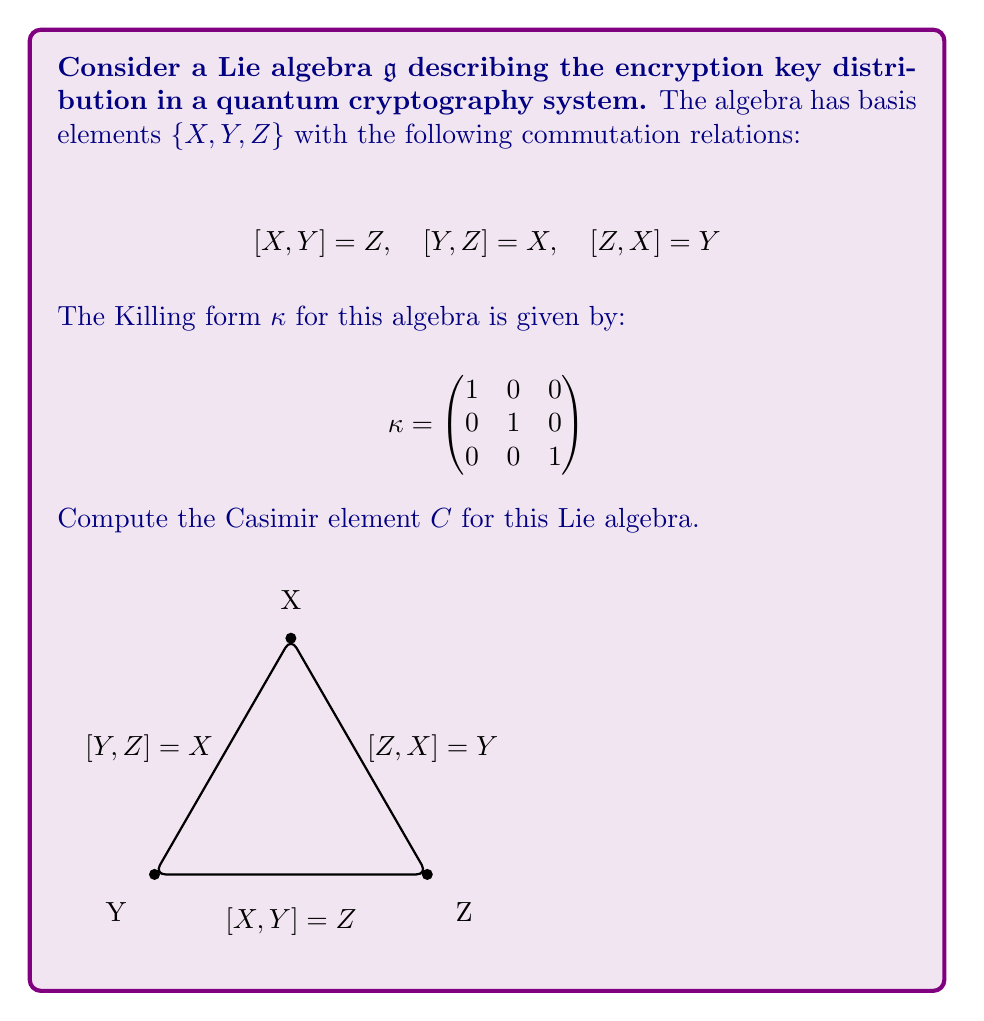Help me with this question. To compute the Casimir element $C$ for this Lie algebra, we'll follow these steps:

1) The Casimir element is defined as $C = \sum_{i,j} \kappa^{ij} X_i X_j$, where $\kappa^{ij}$ are the components of the inverse of the Killing form, and $X_i$ are the basis elements.

2) In this case, the Killing form $\kappa$ is already diagonal and its inverse is identical:

   $$\kappa^{-1} = \begin{pmatrix}
   1 & 0 & 0 \\
   0 & 1 & 0 \\
   0 & 0 & 1
   \end{pmatrix}$$

3) Therefore, the Casimir element is:

   $$C = 1 \cdot X^2 + 1 \cdot Y^2 + 1 \cdot Z^2 = X^2 + Y^2 + Z^2$$

4) To verify that this is indeed the Casimir element, we need to check if it commutes with all elements of the algebra:

   $[C,X] = [X^2,X] + [Y^2,X] + [Z^2,X]$
   
   $= 0 + Y[Y,X] + [Y,X]Y + Z[Z,X] + [Z,X]Z$
   
   $= -YZ - ZY + ZY + YZ = 0$

   Similarly, $[C,Y] = [C,Z] = 0$

5) The Casimir element $C = X^2 + Y^2 + Z^2$ is in the center of the universal enveloping algebra of $\mathfrak{g}$ and represents a quadratic invariant of the system.

In the context of encryption key distribution, this Casimir element could represent a conserved quantity in the quantum cryptography system, potentially related to the information content or entropy of the key distribution process.
Answer: $C = X^2 + Y^2 + Z^2$ 